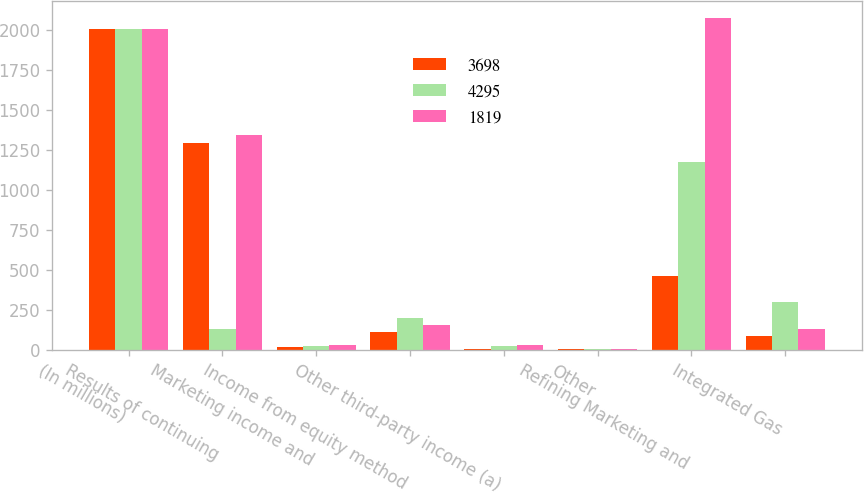Convert chart to OTSL. <chart><loc_0><loc_0><loc_500><loc_500><stacked_bar_chart><ecel><fcel>(In millions)<fcel>Results of continuing<fcel>Marketing income and<fcel>Income from equity method<fcel>Other third-party income (a)<fcel>Other<fcel>Refining Marketing and<fcel>Integrated Gas<nl><fcel>3698<fcel>2009<fcel>1293<fcel>21<fcel>110<fcel>9<fcel>4<fcel>464<fcel>90<nl><fcel>4295<fcel>2008<fcel>132<fcel>27<fcel>201<fcel>26<fcel>6<fcel>1179<fcel>302<nl><fcel>1819<fcel>2007<fcel>1343<fcel>31<fcel>154<fcel>30<fcel>6<fcel>2077<fcel>132<nl></chart> 